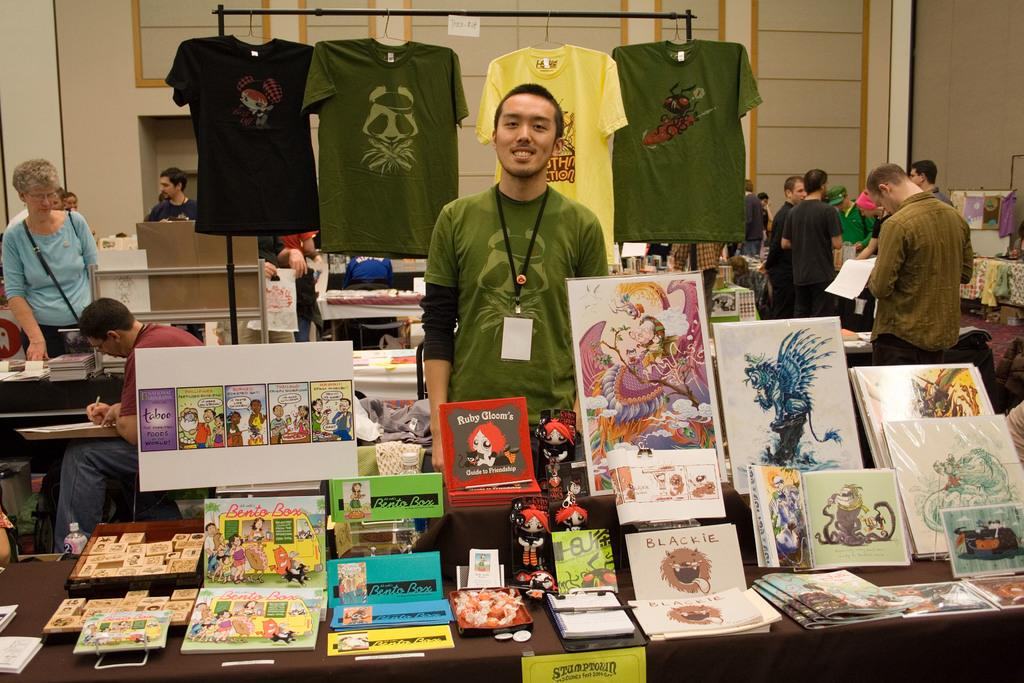Provide a one-sentence caption for the provided image. A man stands behind a table of artwork that is for sale with a yellow sign saying Stumptown taped to the front of the table. 